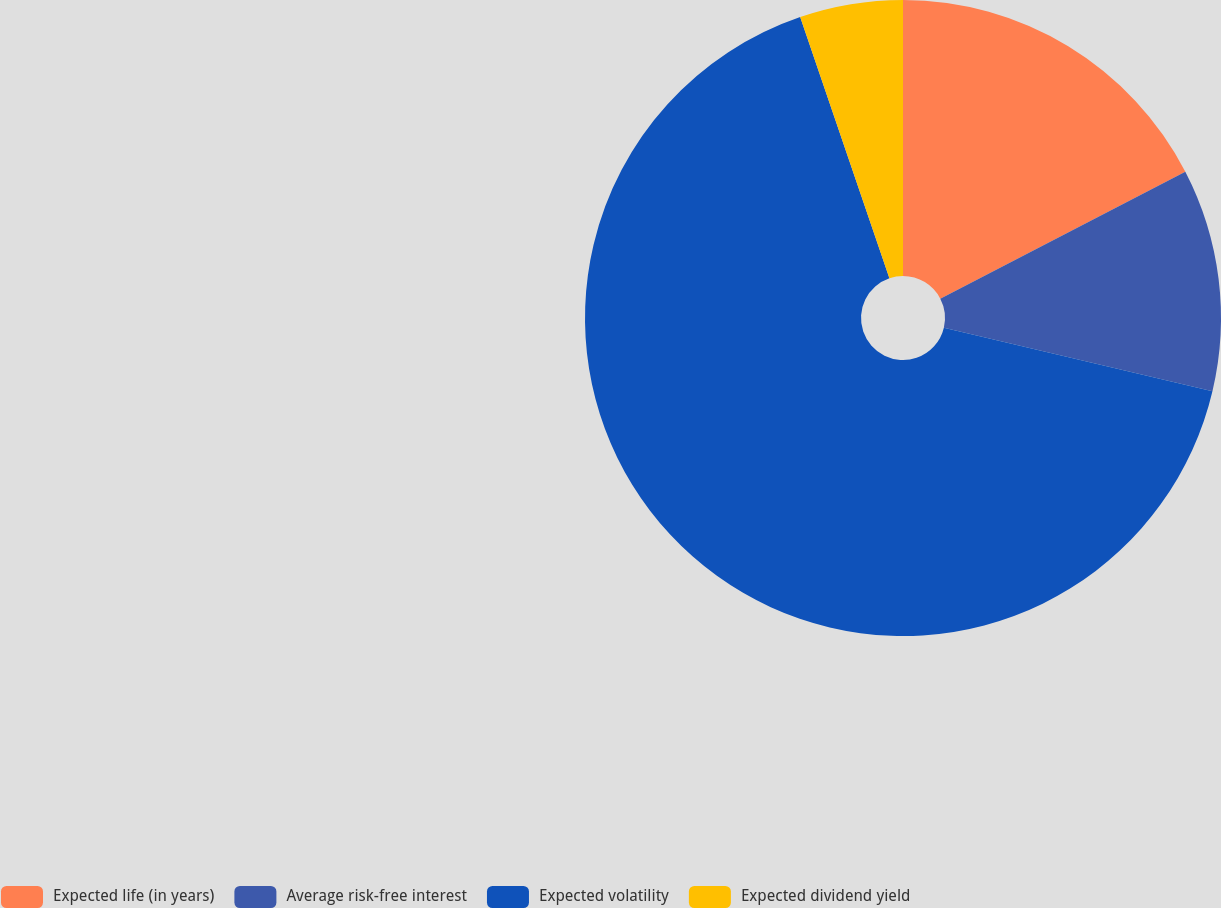Convert chart to OTSL. <chart><loc_0><loc_0><loc_500><loc_500><pie_chart><fcel>Expected life (in years)<fcel>Average risk-free interest<fcel>Expected volatility<fcel>Expected dividend yield<nl><fcel>17.39%<fcel>11.31%<fcel>66.06%<fcel>5.24%<nl></chart> 